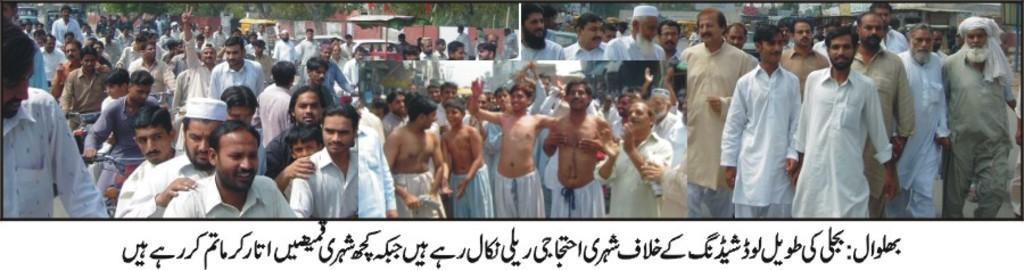Please provide a concise description of this image. In this picture I can see at the bottom there is text, in the middle a group of people are there, it looks like a photo collage. 